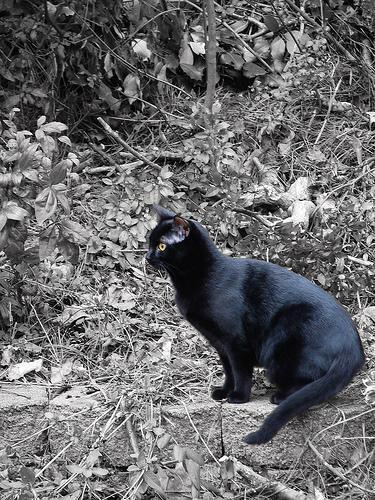How many cats are there?
Give a very brief answer. 1. 